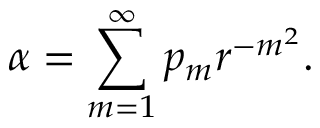<formula> <loc_0><loc_0><loc_500><loc_500>\alpha = \sum _ { m = 1 } ^ { \infty } p _ { m } r ^ { - m ^ { 2 } } .</formula> 